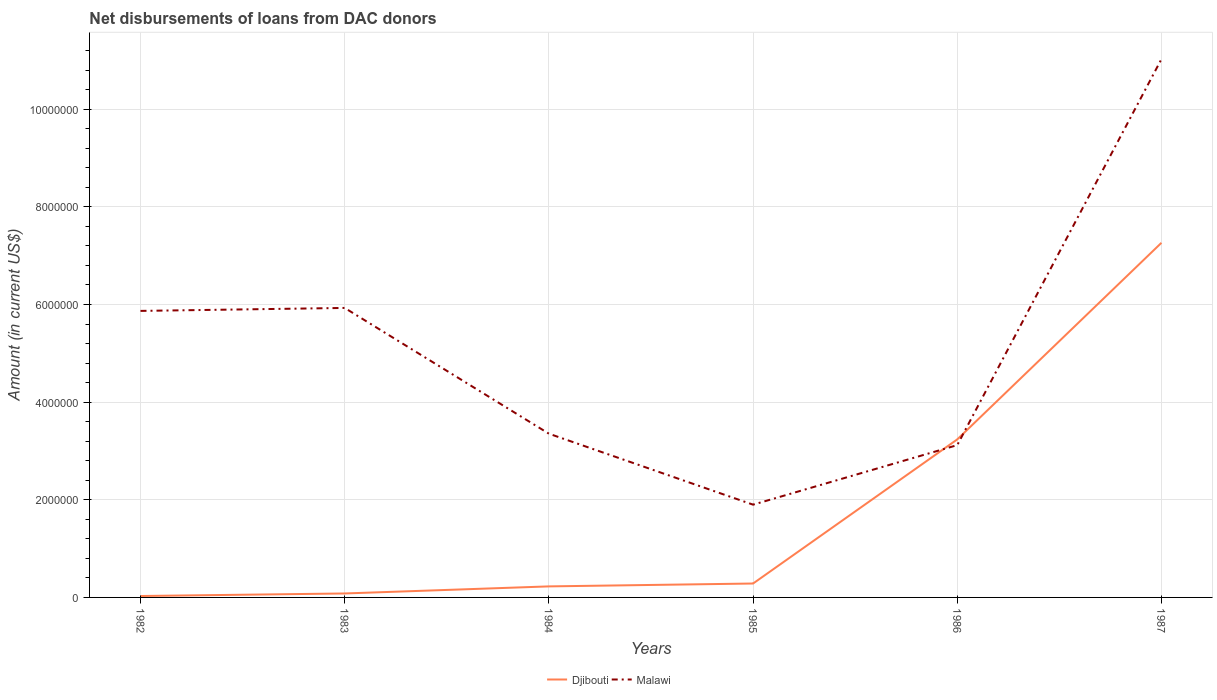How many different coloured lines are there?
Your answer should be very brief. 2. Does the line corresponding to Malawi intersect with the line corresponding to Djibouti?
Ensure brevity in your answer.  Yes. Is the number of lines equal to the number of legend labels?
Make the answer very short. Yes. Across all years, what is the maximum amount of loans disbursed in Djibouti?
Offer a very short reply. 2.90e+04. In which year was the amount of loans disbursed in Malawi maximum?
Your response must be concise. 1985. What is the total amount of loans disbursed in Malawi in the graph?
Ensure brevity in your answer.  3.97e+06. What is the difference between the highest and the second highest amount of loans disbursed in Malawi?
Keep it short and to the point. 9.13e+06. What is the difference between the highest and the lowest amount of loans disbursed in Malawi?
Give a very brief answer. 3. How many lines are there?
Give a very brief answer. 2. What is the difference between two consecutive major ticks on the Y-axis?
Keep it short and to the point. 2.00e+06. Are the values on the major ticks of Y-axis written in scientific E-notation?
Your response must be concise. No. Does the graph contain any zero values?
Make the answer very short. No. Where does the legend appear in the graph?
Your response must be concise. Bottom center. How many legend labels are there?
Provide a short and direct response. 2. What is the title of the graph?
Offer a very short reply. Net disbursements of loans from DAC donors. Does "OECD members" appear as one of the legend labels in the graph?
Provide a succinct answer. No. What is the Amount (in current US$) of Djibouti in 1982?
Ensure brevity in your answer.  2.90e+04. What is the Amount (in current US$) of Malawi in 1982?
Your answer should be very brief. 5.87e+06. What is the Amount (in current US$) of Djibouti in 1983?
Provide a succinct answer. 8.10e+04. What is the Amount (in current US$) of Malawi in 1983?
Provide a succinct answer. 5.93e+06. What is the Amount (in current US$) of Djibouti in 1984?
Ensure brevity in your answer.  2.26e+05. What is the Amount (in current US$) in Malawi in 1984?
Give a very brief answer. 3.35e+06. What is the Amount (in current US$) of Djibouti in 1985?
Give a very brief answer. 2.85e+05. What is the Amount (in current US$) in Malawi in 1985?
Your answer should be compact. 1.90e+06. What is the Amount (in current US$) in Djibouti in 1986?
Keep it short and to the point. 3.24e+06. What is the Amount (in current US$) in Malawi in 1986?
Provide a succinct answer. 3.12e+06. What is the Amount (in current US$) of Djibouti in 1987?
Make the answer very short. 7.26e+06. What is the Amount (in current US$) of Malawi in 1987?
Provide a succinct answer. 1.10e+07. Across all years, what is the maximum Amount (in current US$) of Djibouti?
Your response must be concise. 7.26e+06. Across all years, what is the maximum Amount (in current US$) of Malawi?
Ensure brevity in your answer.  1.10e+07. Across all years, what is the minimum Amount (in current US$) in Djibouti?
Your answer should be compact. 2.90e+04. Across all years, what is the minimum Amount (in current US$) of Malawi?
Ensure brevity in your answer.  1.90e+06. What is the total Amount (in current US$) of Djibouti in the graph?
Make the answer very short. 1.11e+07. What is the total Amount (in current US$) of Malawi in the graph?
Ensure brevity in your answer.  3.12e+07. What is the difference between the Amount (in current US$) of Djibouti in 1982 and that in 1983?
Offer a very short reply. -5.20e+04. What is the difference between the Amount (in current US$) of Malawi in 1982 and that in 1983?
Provide a short and direct response. -6.10e+04. What is the difference between the Amount (in current US$) of Djibouti in 1982 and that in 1984?
Keep it short and to the point. -1.97e+05. What is the difference between the Amount (in current US$) in Malawi in 1982 and that in 1984?
Your response must be concise. 2.52e+06. What is the difference between the Amount (in current US$) of Djibouti in 1982 and that in 1985?
Your response must be concise. -2.56e+05. What is the difference between the Amount (in current US$) in Malawi in 1982 and that in 1985?
Offer a very short reply. 3.97e+06. What is the difference between the Amount (in current US$) of Djibouti in 1982 and that in 1986?
Give a very brief answer. -3.21e+06. What is the difference between the Amount (in current US$) of Malawi in 1982 and that in 1986?
Offer a very short reply. 2.75e+06. What is the difference between the Amount (in current US$) of Djibouti in 1982 and that in 1987?
Make the answer very short. -7.24e+06. What is the difference between the Amount (in current US$) in Malawi in 1982 and that in 1987?
Offer a very short reply. -5.16e+06. What is the difference between the Amount (in current US$) in Djibouti in 1983 and that in 1984?
Offer a very short reply. -1.45e+05. What is the difference between the Amount (in current US$) in Malawi in 1983 and that in 1984?
Offer a terse response. 2.58e+06. What is the difference between the Amount (in current US$) of Djibouti in 1983 and that in 1985?
Offer a terse response. -2.04e+05. What is the difference between the Amount (in current US$) in Malawi in 1983 and that in 1985?
Your answer should be very brief. 4.03e+06. What is the difference between the Amount (in current US$) in Djibouti in 1983 and that in 1986?
Provide a succinct answer. -3.16e+06. What is the difference between the Amount (in current US$) of Malawi in 1983 and that in 1986?
Your answer should be very brief. 2.81e+06. What is the difference between the Amount (in current US$) in Djibouti in 1983 and that in 1987?
Your answer should be compact. -7.18e+06. What is the difference between the Amount (in current US$) of Malawi in 1983 and that in 1987?
Offer a very short reply. -5.10e+06. What is the difference between the Amount (in current US$) of Djibouti in 1984 and that in 1985?
Offer a terse response. -5.90e+04. What is the difference between the Amount (in current US$) of Malawi in 1984 and that in 1985?
Offer a very short reply. 1.45e+06. What is the difference between the Amount (in current US$) of Djibouti in 1984 and that in 1986?
Your answer should be compact. -3.01e+06. What is the difference between the Amount (in current US$) in Malawi in 1984 and that in 1986?
Provide a succinct answer. 2.34e+05. What is the difference between the Amount (in current US$) in Djibouti in 1984 and that in 1987?
Your answer should be compact. -7.04e+06. What is the difference between the Amount (in current US$) in Malawi in 1984 and that in 1987?
Give a very brief answer. -7.67e+06. What is the difference between the Amount (in current US$) of Djibouti in 1985 and that in 1986?
Provide a short and direct response. -2.95e+06. What is the difference between the Amount (in current US$) of Malawi in 1985 and that in 1986?
Keep it short and to the point. -1.22e+06. What is the difference between the Amount (in current US$) in Djibouti in 1985 and that in 1987?
Give a very brief answer. -6.98e+06. What is the difference between the Amount (in current US$) in Malawi in 1985 and that in 1987?
Your response must be concise. -9.13e+06. What is the difference between the Amount (in current US$) of Djibouti in 1986 and that in 1987?
Make the answer very short. -4.03e+06. What is the difference between the Amount (in current US$) of Malawi in 1986 and that in 1987?
Your answer should be compact. -7.91e+06. What is the difference between the Amount (in current US$) in Djibouti in 1982 and the Amount (in current US$) in Malawi in 1983?
Your answer should be very brief. -5.90e+06. What is the difference between the Amount (in current US$) of Djibouti in 1982 and the Amount (in current US$) of Malawi in 1984?
Your answer should be very brief. -3.32e+06. What is the difference between the Amount (in current US$) of Djibouti in 1982 and the Amount (in current US$) of Malawi in 1985?
Provide a short and direct response. -1.87e+06. What is the difference between the Amount (in current US$) of Djibouti in 1982 and the Amount (in current US$) of Malawi in 1986?
Make the answer very short. -3.09e+06. What is the difference between the Amount (in current US$) of Djibouti in 1982 and the Amount (in current US$) of Malawi in 1987?
Provide a succinct answer. -1.10e+07. What is the difference between the Amount (in current US$) in Djibouti in 1983 and the Amount (in current US$) in Malawi in 1984?
Keep it short and to the point. -3.27e+06. What is the difference between the Amount (in current US$) of Djibouti in 1983 and the Amount (in current US$) of Malawi in 1985?
Ensure brevity in your answer.  -1.82e+06. What is the difference between the Amount (in current US$) of Djibouti in 1983 and the Amount (in current US$) of Malawi in 1986?
Make the answer very short. -3.04e+06. What is the difference between the Amount (in current US$) of Djibouti in 1983 and the Amount (in current US$) of Malawi in 1987?
Make the answer very short. -1.09e+07. What is the difference between the Amount (in current US$) in Djibouti in 1984 and the Amount (in current US$) in Malawi in 1985?
Your answer should be very brief. -1.67e+06. What is the difference between the Amount (in current US$) in Djibouti in 1984 and the Amount (in current US$) in Malawi in 1986?
Give a very brief answer. -2.89e+06. What is the difference between the Amount (in current US$) in Djibouti in 1984 and the Amount (in current US$) in Malawi in 1987?
Offer a terse response. -1.08e+07. What is the difference between the Amount (in current US$) of Djibouti in 1985 and the Amount (in current US$) of Malawi in 1986?
Give a very brief answer. -2.84e+06. What is the difference between the Amount (in current US$) in Djibouti in 1985 and the Amount (in current US$) in Malawi in 1987?
Provide a short and direct response. -1.07e+07. What is the difference between the Amount (in current US$) of Djibouti in 1986 and the Amount (in current US$) of Malawi in 1987?
Offer a terse response. -7.79e+06. What is the average Amount (in current US$) of Djibouti per year?
Your answer should be very brief. 1.85e+06. What is the average Amount (in current US$) of Malawi per year?
Your answer should be compact. 5.20e+06. In the year 1982, what is the difference between the Amount (in current US$) of Djibouti and Amount (in current US$) of Malawi?
Provide a short and direct response. -5.84e+06. In the year 1983, what is the difference between the Amount (in current US$) in Djibouti and Amount (in current US$) in Malawi?
Ensure brevity in your answer.  -5.85e+06. In the year 1984, what is the difference between the Amount (in current US$) in Djibouti and Amount (in current US$) in Malawi?
Ensure brevity in your answer.  -3.13e+06. In the year 1985, what is the difference between the Amount (in current US$) in Djibouti and Amount (in current US$) in Malawi?
Your answer should be very brief. -1.62e+06. In the year 1986, what is the difference between the Amount (in current US$) in Djibouti and Amount (in current US$) in Malawi?
Ensure brevity in your answer.  1.17e+05. In the year 1987, what is the difference between the Amount (in current US$) in Djibouti and Amount (in current US$) in Malawi?
Offer a terse response. -3.76e+06. What is the ratio of the Amount (in current US$) in Djibouti in 1982 to that in 1983?
Give a very brief answer. 0.36. What is the ratio of the Amount (in current US$) of Malawi in 1982 to that in 1983?
Offer a terse response. 0.99. What is the ratio of the Amount (in current US$) of Djibouti in 1982 to that in 1984?
Keep it short and to the point. 0.13. What is the ratio of the Amount (in current US$) of Malawi in 1982 to that in 1984?
Provide a short and direct response. 1.75. What is the ratio of the Amount (in current US$) of Djibouti in 1982 to that in 1985?
Provide a short and direct response. 0.1. What is the ratio of the Amount (in current US$) in Malawi in 1982 to that in 1985?
Provide a short and direct response. 3.09. What is the ratio of the Amount (in current US$) in Djibouti in 1982 to that in 1986?
Ensure brevity in your answer.  0.01. What is the ratio of the Amount (in current US$) in Malawi in 1982 to that in 1986?
Your answer should be very brief. 1.88. What is the ratio of the Amount (in current US$) in Djibouti in 1982 to that in 1987?
Provide a short and direct response. 0. What is the ratio of the Amount (in current US$) of Malawi in 1982 to that in 1987?
Your answer should be compact. 0.53. What is the ratio of the Amount (in current US$) of Djibouti in 1983 to that in 1984?
Give a very brief answer. 0.36. What is the ratio of the Amount (in current US$) in Malawi in 1983 to that in 1984?
Make the answer very short. 1.77. What is the ratio of the Amount (in current US$) in Djibouti in 1983 to that in 1985?
Provide a succinct answer. 0.28. What is the ratio of the Amount (in current US$) in Malawi in 1983 to that in 1985?
Give a very brief answer. 3.12. What is the ratio of the Amount (in current US$) in Djibouti in 1983 to that in 1986?
Offer a very short reply. 0.03. What is the ratio of the Amount (in current US$) of Malawi in 1983 to that in 1986?
Your answer should be very brief. 1.9. What is the ratio of the Amount (in current US$) in Djibouti in 1983 to that in 1987?
Your answer should be compact. 0.01. What is the ratio of the Amount (in current US$) of Malawi in 1983 to that in 1987?
Make the answer very short. 0.54. What is the ratio of the Amount (in current US$) in Djibouti in 1984 to that in 1985?
Keep it short and to the point. 0.79. What is the ratio of the Amount (in current US$) in Malawi in 1984 to that in 1985?
Give a very brief answer. 1.77. What is the ratio of the Amount (in current US$) of Djibouti in 1984 to that in 1986?
Provide a succinct answer. 0.07. What is the ratio of the Amount (in current US$) in Malawi in 1984 to that in 1986?
Keep it short and to the point. 1.07. What is the ratio of the Amount (in current US$) in Djibouti in 1984 to that in 1987?
Keep it short and to the point. 0.03. What is the ratio of the Amount (in current US$) in Malawi in 1984 to that in 1987?
Make the answer very short. 0.3. What is the ratio of the Amount (in current US$) of Djibouti in 1985 to that in 1986?
Your response must be concise. 0.09. What is the ratio of the Amount (in current US$) in Malawi in 1985 to that in 1986?
Your answer should be compact. 0.61. What is the ratio of the Amount (in current US$) in Djibouti in 1985 to that in 1987?
Offer a very short reply. 0.04. What is the ratio of the Amount (in current US$) in Malawi in 1985 to that in 1987?
Make the answer very short. 0.17. What is the ratio of the Amount (in current US$) in Djibouti in 1986 to that in 1987?
Provide a short and direct response. 0.45. What is the ratio of the Amount (in current US$) in Malawi in 1986 to that in 1987?
Offer a terse response. 0.28. What is the difference between the highest and the second highest Amount (in current US$) in Djibouti?
Provide a succinct answer. 4.03e+06. What is the difference between the highest and the second highest Amount (in current US$) of Malawi?
Provide a succinct answer. 5.10e+06. What is the difference between the highest and the lowest Amount (in current US$) of Djibouti?
Ensure brevity in your answer.  7.24e+06. What is the difference between the highest and the lowest Amount (in current US$) of Malawi?
Your response must be concise. 9.13e+06. 